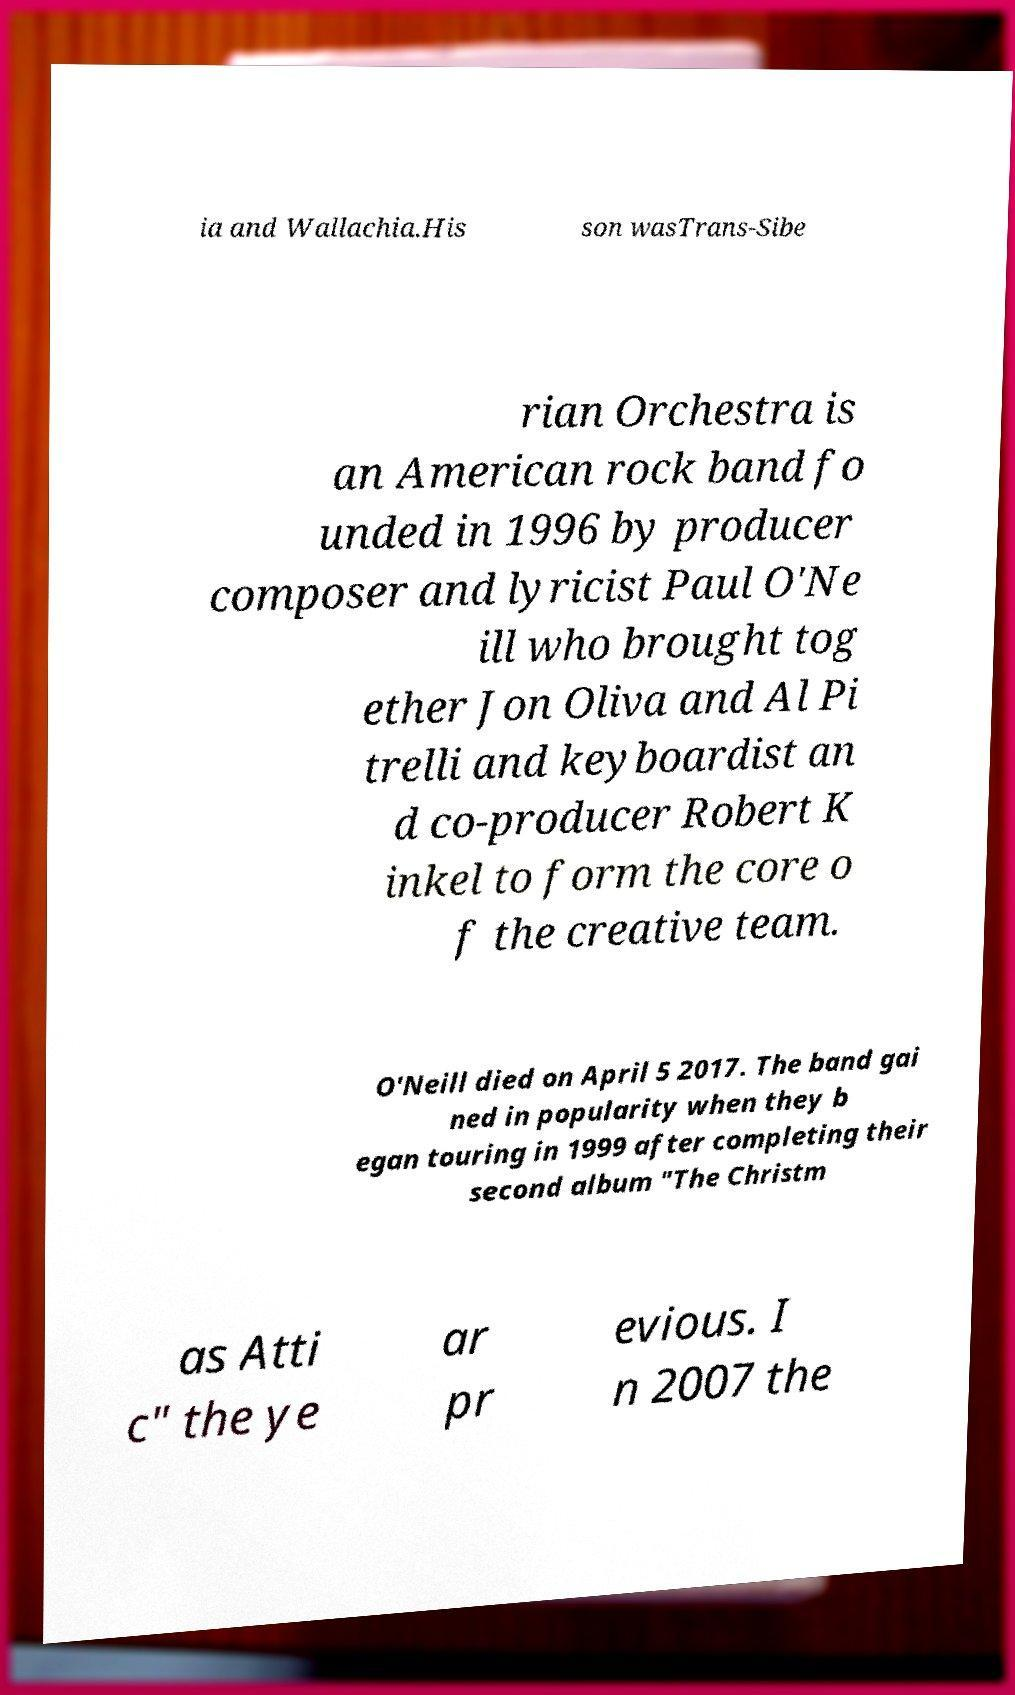Could you assist in decoding the text presented in this image and type it out clearly? ia and Wallachia.His son wasTrans-Sibe rian Orchestra is an American rock band fo unded in 1996 by producer composer and lyricist Paul O'Ne ill who brought tog ether Jon Oliva and Al Pi trelli and keyboardist an d co-producer Robert K inkel to form the core o f the creative team. O'Neill died on April 5 2017. The band gai ned in popularity when they b egan touring in 1999 after completing their second album "The Christm as Atti c" the ye ar pr evious. I n 2007 the 